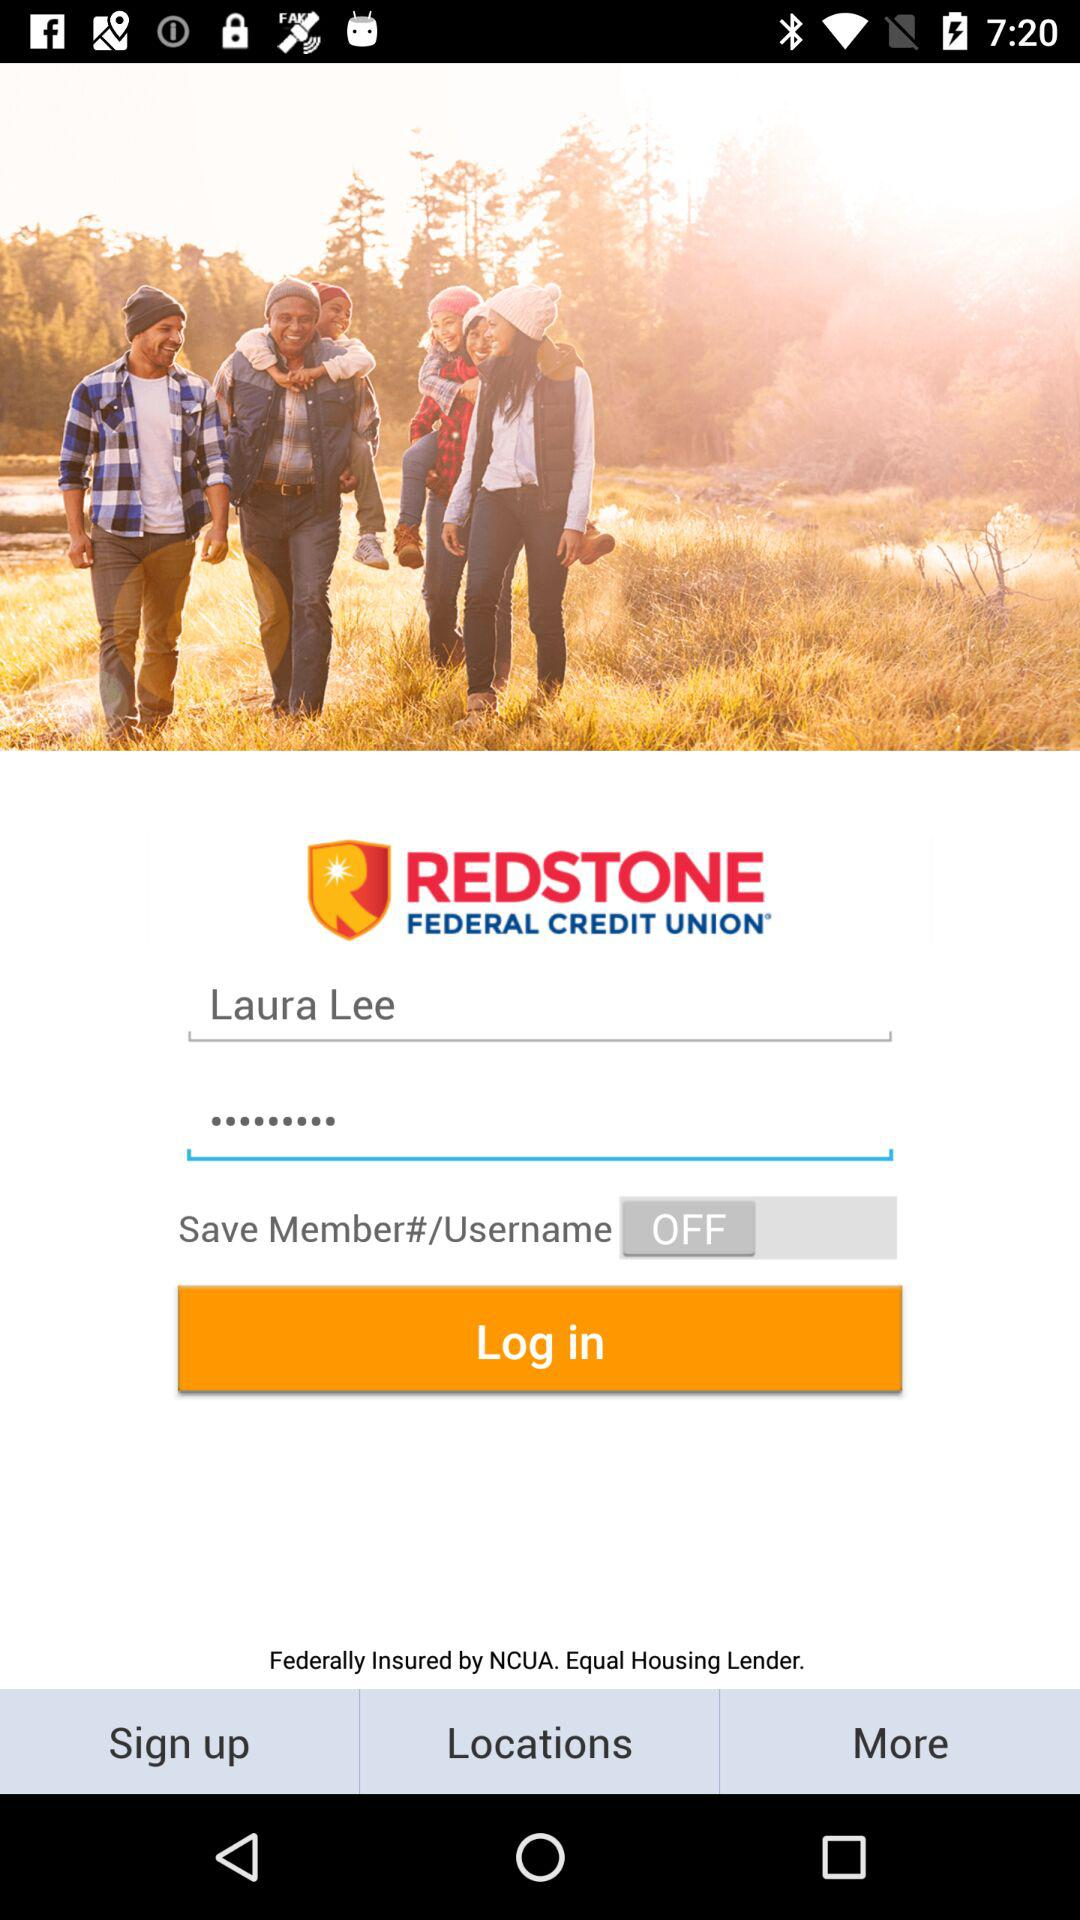What is the user name? The user name is Laura Lee. 